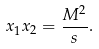<formula> <loc_0><loc_0><loc_500><loc_500>x _ { 1 } x _ { 2 } = \frac { M ^ { 2 } } { s } .</formula> 